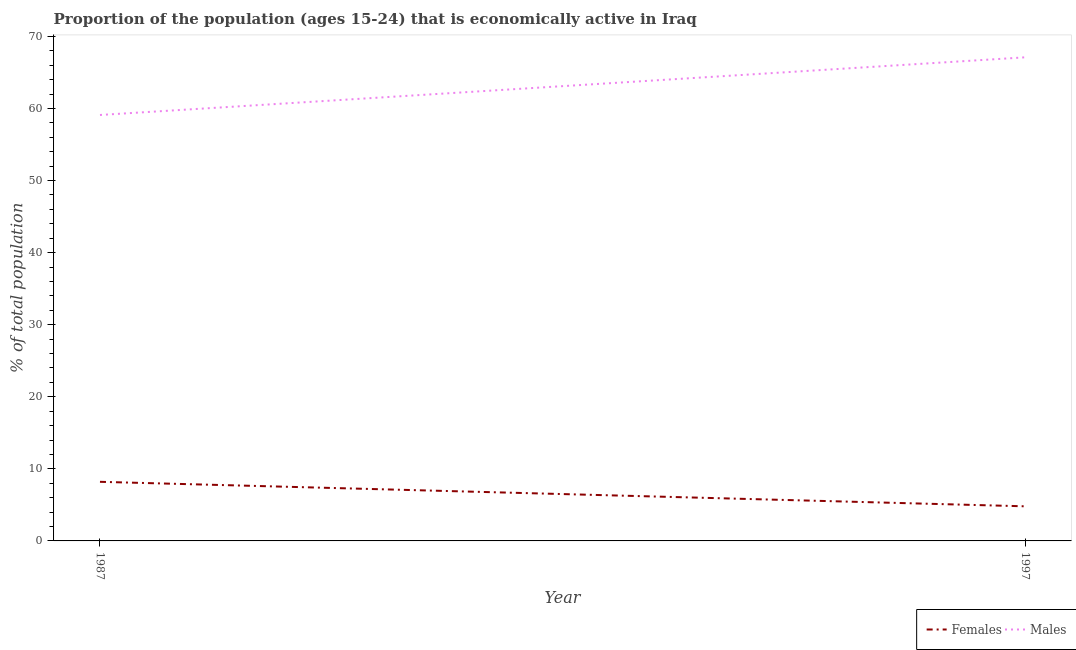What is the percentage of economically active female population in 1997?
Ensure brevity in your answer.  4.8. Across all years, what is the maximum percentage of economically active male population?
Provide a succinct answer. 67.1. Across all years, what is the minimum percentage of economically active female population?
Provide a succinct answer. 4.8. In which year was the percentage of economically active female population maximum?
Your answer should be compact. 1987. What is the total percentage of economically active male population in the graph?
Your answer should be compact. 126.2. What is the difference between the percentage of economically active male population in 1987 and that in 1997?
Your answer should be very brief. -8. What is the difference between the percentage of economically active female population in 1987 and the percentage of economically active male population in 1997?
Make the answer very short. -58.9. What is the average percentage of economically active male population per year?
Your answer should be compact. 63.1. In the year 1987, what is the difference between the percentage of economically active female population and percentage of economically active male population?
Ensure brevity in your answer.  -50.9. What is the ratio of the percentage of economically active female population in 1987 to that in 1997?
Offer a very short reply. 1.71. Is the percentage of economically active male population in 1987 less than that in 1997?
Provide a short and direct response. Yes. How many lines are there?
Give a very brief answer. 2. Are the values on the major ticks of Y-axis written in scientific E-notation?
Your response must be concise. No. Does the graph contain any zero values?
Make the answer very short. No. Does the graph contain grids?
Offer a terse response. No. Where does the legend appear in the graph?
Offer a very short reply. Bottom right. How many legend labels are there?
Your answer should be compact. 2. How are the legend labels stacked?
Offer a very short reply. Horizontal. What is the title of the graph?
Provide a short and direct response. Proportion of the population (ages 15-24) that is economically active in Iraq. Does "Female labor force" appear as one of the legend labels in the graph?
Offer a terse response. No. What is the label or title of the X-axis?
Provide a short and direct response. Year. What is the label or title of the Y-axis?
Your answer should be compact. % of total population. What is the % of total population of Females in 1987?
Your answer should be very brief. 8.2. What is the % of total population of Males in 1987?
Your response must be concise. 59.1. What is the % of total population in Females in 1997?
Your answer should be compact. 4.8. What is the % of total population in Males in 1997?
Give a very brief answer. 67.1. Across all years, what is the maximum % of total population of Females?
Your response must be concise. 8.2. Across all years, what is the maximum % of total population in Males?
Make the answer very short. 67.1. Across all years, what is the minimum % of total population of Females?
Offer a very short reply. 4.8. Across all years, what is the minimum % of total population of Males?
Your answer should be very brief. 59.1. What is the total % of total population in Males in the graph?
Provide a short and direct response. 126.2. What is the difference between the % of total population in Females in 1987 and that in 1997?
Offer a very short reply. 3.4. What is the difference between the % of total population of Females in 1987 and the % of total population of Males in 1997?
Offer a very short reply. -58.9. What is the average % of total population of Females per year?
Provide a succinct answer. 6.5. What is the average % of total population in Males per year?
Keep it short and to the point. 63.1. In the year 1987, what is the difference between the % of total population of Females and % of total population of Males?
Provide a succinct answer. -50.9. In the year 1997, what is the difference between the % of total population of Females and % of total population of Males?
Provide a succinct answer. -62.3. What is the ratio of the % of total population in Females in 1987 to that in 1997?
Provide a short and direct response. 1.71. What is the ratio of the % of total population in Males in 1987 to that in 1997?
Your answer should be compact. 0.88. 